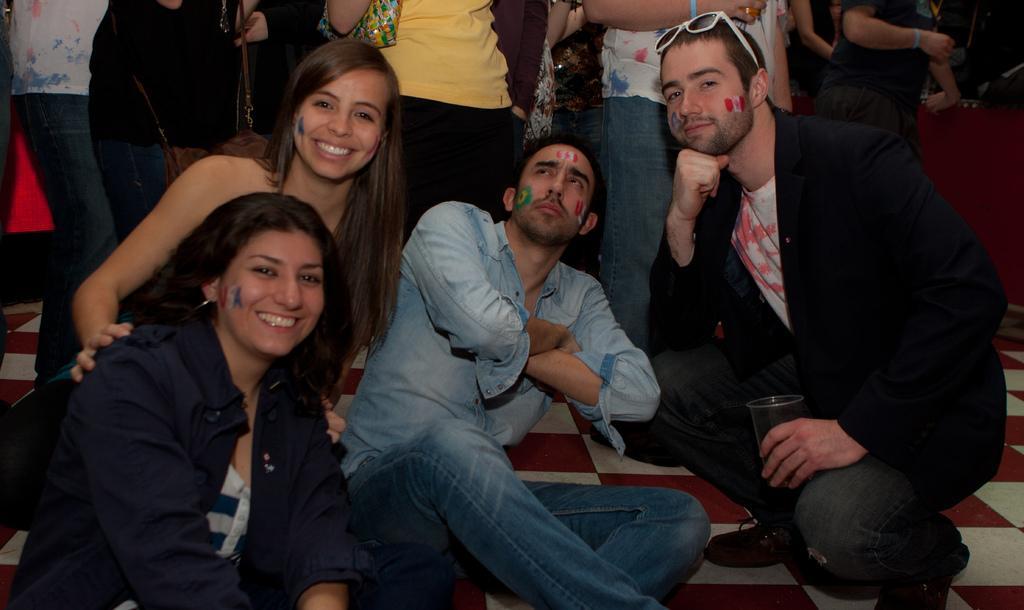Describe this image in one or two sentences. In this image we can see people. These two people are smiling. This man is holding a cup. This person is giving a still. 